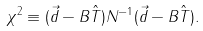Convert formula to latex. <formula><loc_0><loc_0><loc_500><loc_500>\chi ^ { 2 } \equiv ( { \vec { d } } - { B } \hat { T } ) { N ^ { - 1 } } ( { \vec { d } } - { B } \hat { T } ) .</formula> 